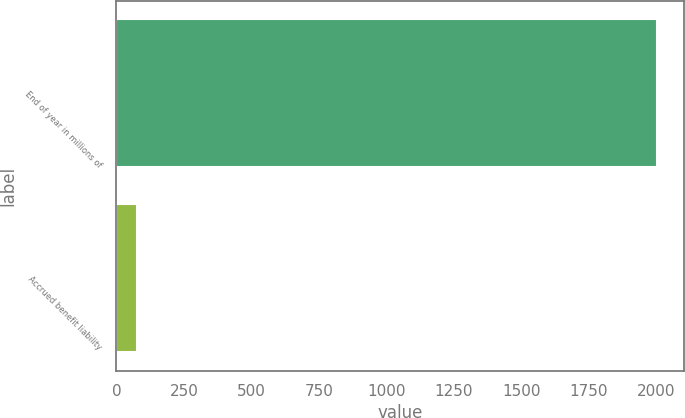<chart> <loc_0><loc_0><loc_500><loc_500><bar_chart><fcel>End of year in millions of<fcel>Accrued benefit liability<nl><fcel>2003<fcel>76<nl></chart> 